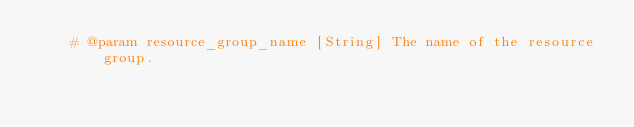<code> <loc_0><loc_0><loc_500><loc_500><_Ruby_>    # @param resource_group_name [String] The name of the resource group.</code> 